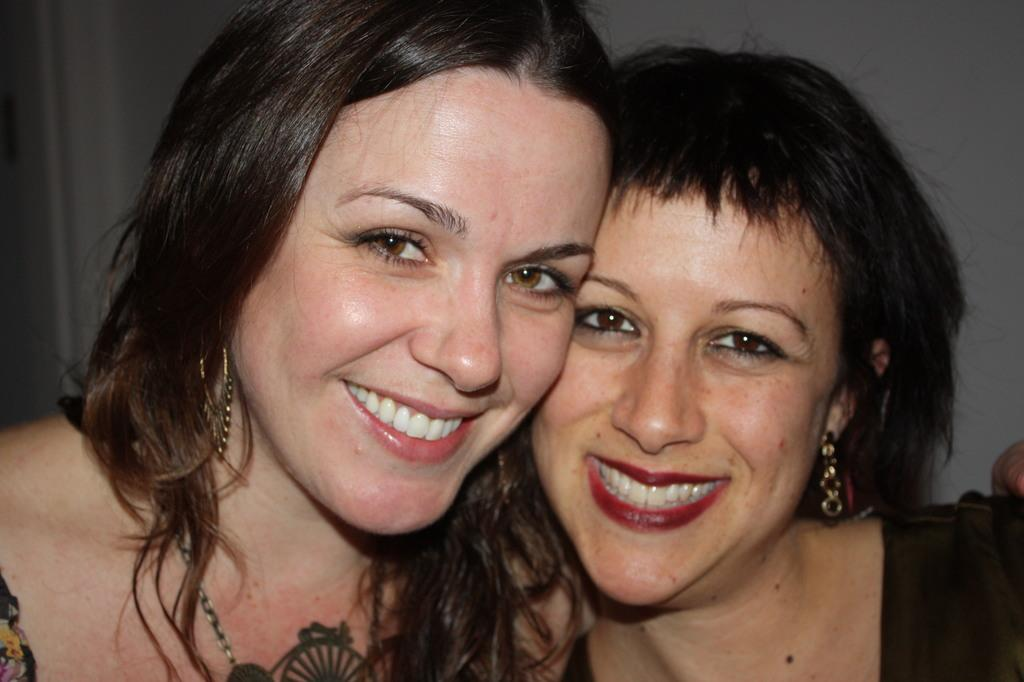How many people are in the image? There are two women in the image. What expressions do the women have on their faces? The women have pretty smiles on their faces. What type of pan can be seen hanging on the wall in the image? There is no pan visible in the image; it only features two women with pretty smiles. 